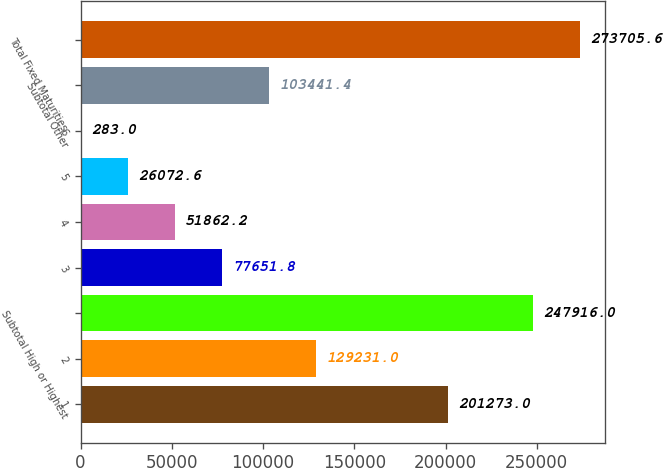Convert chart to OTSL. <chart><loc_0><loc_0><loc_500><loc_500><bar_chart><fcel>1<fcel>2<fcel>Subtotal High or Highest<fcel>3<fcel>4<fcel>5<fcel>6<fcel>Subtotal Other<fcel>Total Fixed Maturities<nl><fcel>201273<fcel>129231<fcel>247916<fcel>77651.8<fcel>51862.2<fcel>26072.6<fcel>283<fcel>103441<fcel>273706<nl></chart> 